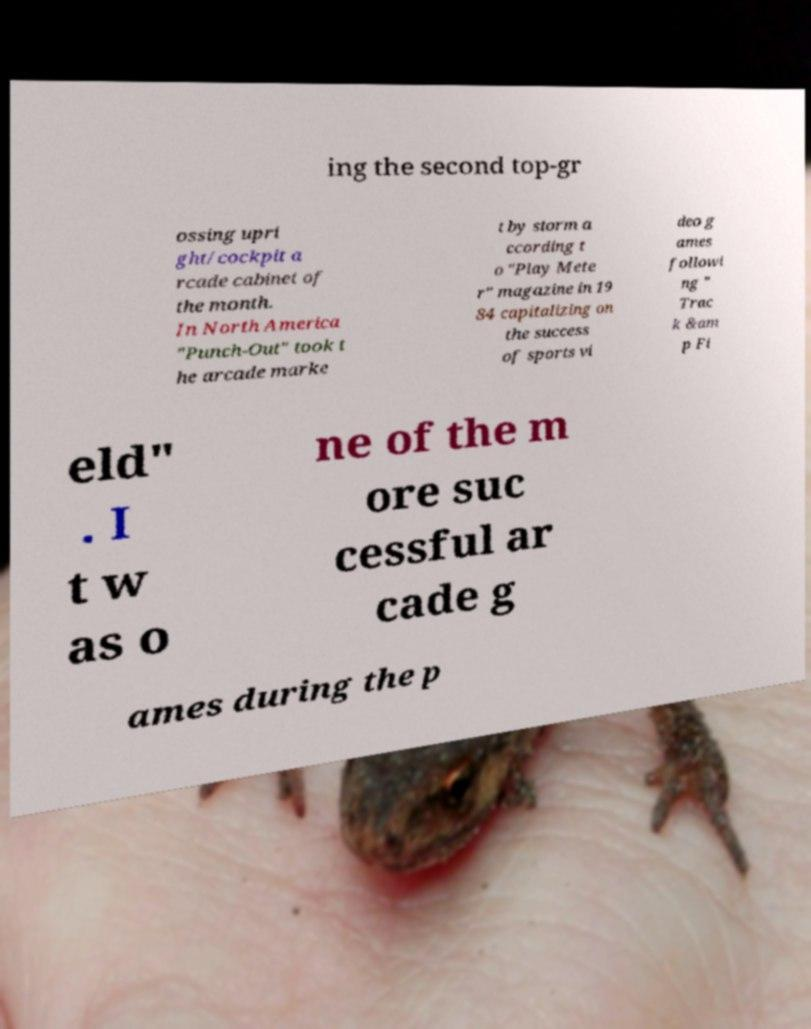For documentation purposes, I need the text within this image transcribed. Could you provide that? ing the second top-gr ossing upri ght/cockpit a rcade cabinet of the month. In North America "Punch-Out" took t he arcade marke t by storm a ccording t o "Play Mete r" magazine in 19 84 capitalizing on the success of sports vi deo g ames followi ng " Trac k &am p Fi eld" . I t w as o ne of the m ore suc cessful ar cade g ames during the p 